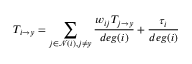<formula> <loc_0><loc_0><loc_500><loc_500>T _ { i \rightarrow y } = \sum _ { j \in \mathcal { N } ( i ) , j \neq y } \frac { w _ { i j } T _ { j \rightarrow y } } { d e g ( i ) } + \frac { \tau _ { i } } { d e g ( i ) }</formula> 